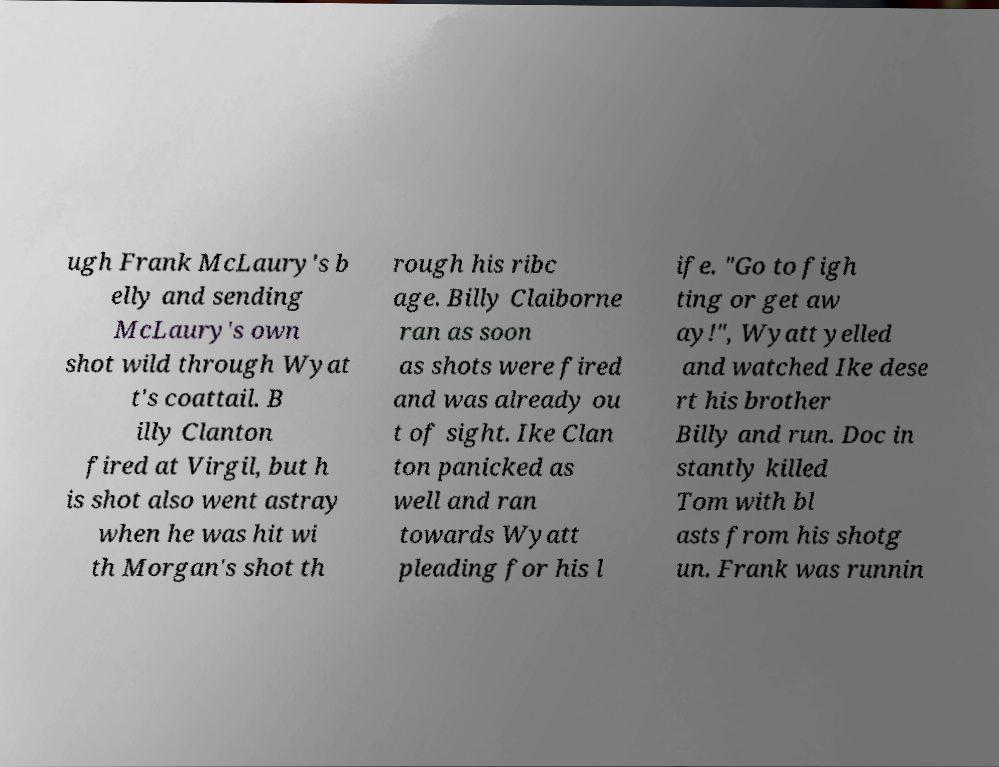Could you extract and type out the text from this image? ugh Frank McLaury's b elly and sending McLaury's own shot wild through Wyat t's coattail. B illy Clanton fired at Virgil, but h is shot also went astray when he was hit wi th Morgan's shot th rough his ribc age. Billy Claiborne ran as soon as shots were fired and was already ou t of sight. Ike Clan ton panicked as well and ran towards Wyatt pleading for his l ife. "Go to figh ting or get aw ay!", Wyatt yelled and watched Ike dese rt his brother Billy and run. Doc in stantly killed Tom with bl asts from his shotg un. Frank was runnin 